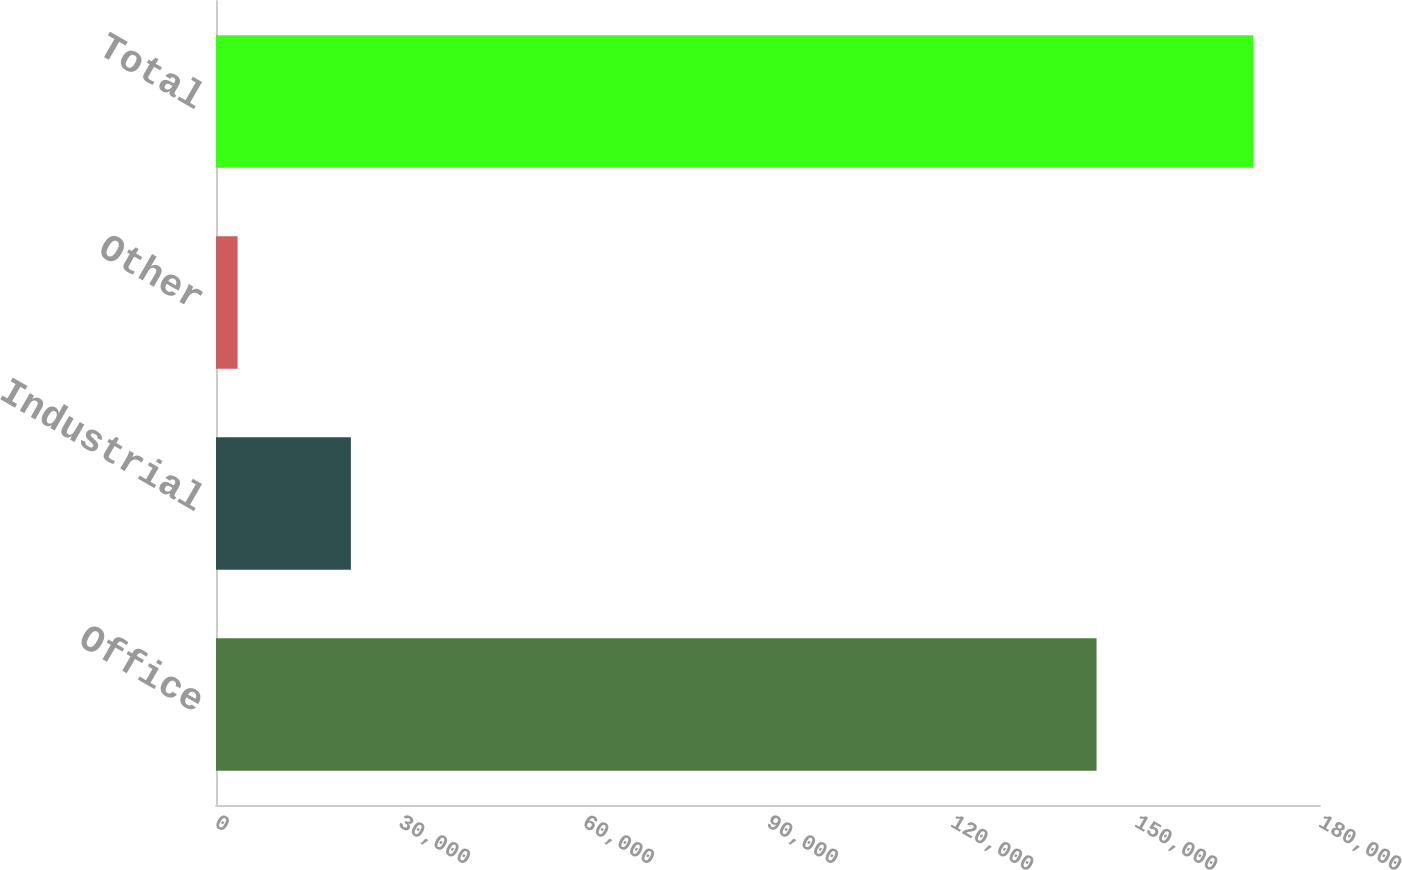Convert chart to OTSL. <chart><loc_0><loc_0><loc_500><loc_500><bar_chart><fcel>Office<fcel>Industrial<fcel>Other<fcel>Total<nl><fcel>143567<fcel>21991<fcel>3519<fcel>169077<nl></chart> 